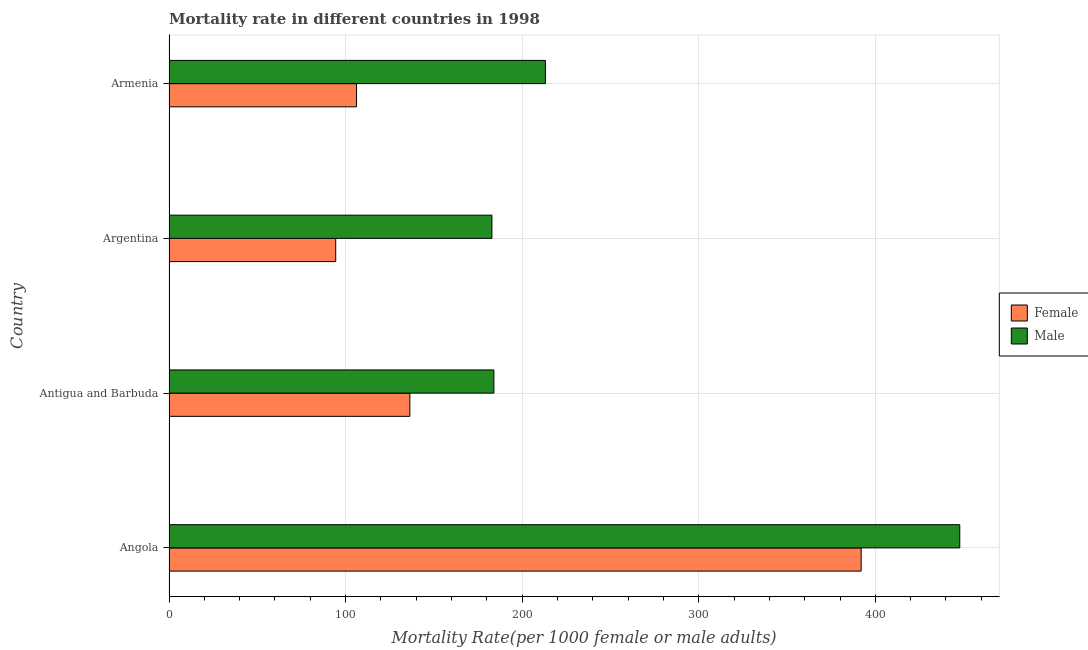How many groups of bars are there?
Make the answer very short. 4. How many bars are there on the 1st tick from the top?
Your response must be concise. 2. What is the label of the 2nd group of bars from the top?
Offer a very short reply. Argentina. In how many cases, is the number of bars for a given country not equal to the number of legend labels?
Offer a very short reply. 0. What is the female mortality rate in Antigua and Barbuda?
Provide a succinct answer. 136.4. Across all countries, what is the maximum female mortality rate?
Your answer should be compact. 391.99. Across all countries, what is the minimum male mortality rate?
Your answer should be compact. 182.88. In which country was the male mortality rate maximum?
Offer a very short reply. Angola. What is the total male mortality rate in the graph?
Offer a terse response. 1027.86. What is the difference between the male mortality rate in Angola and that in Antigua and Barbuda?
Your answer should be very brief. 263.83. What is the difference between the female mortality rate in Argentina and the male mortality rate in Armenia?
Offer a very short reply. -118.75. What is the average female mortality rate per country?
Your response must be concise. 182.25. What is the difference between the female mortality rate and male mortality rate in Argentina?
Your answer should be compact. -88.47. In how many countries, is the male mortality rate greater than 200 ?
Provide a short and direct response. 2. What is the ratio of the female mortality rate in Angola to that in Argentina?
Ensure brevity in your answer.  4.15. Is the difference between the female mortality rate in Angola and Argentina greater than the difference between the male mortality rate in Angola and Argentina?
Your response must be concise. Yes. What is the difference between the highest and the second highest male mortality rate?
Provide a short and direct response. 234.66. What is the difference between the highest and the lowest female mortality rate?
Your answer should be compact. 297.57. In how many countries, is the male mortality rate greater than the average male mortality rate taken over all countries?
Provide a short and direct response. 1. How many bars are there?
Your answer should be compact. 8. Are all the bars in the graph horizontal?
Your response must be concise. Yes. How many countries are there in the graph?
Keep it short and to the point. 4. Does the graph contain grids?
Give a very brief answer. Yes. Where does the legend appear in the graph?
Your answer should be very brief. Center right. How many legend labels are there?
Your answer should be compact. 2. What is the title of the graph?
Make the answer very short. Mortality rate in different countries in 1998. What is the label or title of the X-axis?
Provide a succinct answer. Mortality Rate(per 1000 female or male adults). What is the Mortality Rate(per 1000 female or male adults) of Female in Angola?
Your answer should be very brief. 391.99. What is the Mortality Rate(per 1000 female or male adults) of Male in Angola?
Give a very brief answer. 447.82. What is the Mortality Rate(per 1000 female or male adults) of Female in Antigua and Barbuda?
Your answer should be compact. 136.4. What is the Mortality Rate(per 1000 female or male adults) in Male in Antigua and Barbuda?
Offer a very short reply. 183.99. What is the Mortality Rate(per 1000 female or male adults) in Female in Argentina?
Provide a short and direct response. 94.41. What is the Mortality Rate(per 1000 female or male adults) in Male in Argentina?
Give a very brief answer. 182.88. What is the Mortality Rate(per 1000 female or male adults) of Female in Armenia?
Keep it short and to the point. 106.2. What is the Mortality Rate(per 1000 female or male adults) in Male in Armenia?
Your answer should be compact. 213.16. Across all countries, what is the maximum Mortality Rate(per 1000 female or male adults) in Female?
Your answer should be very brief. 391.99. Across all countries, what is the maximum Mortality Rate(per 1000 female or male adults) in Male?
Your answer should be compact. 447.82. Across all countries, what is the minimum Mortality Rate(per 1000 female or male adults) of Female?
Your answer should be compact. 94.41. Across all countries, what is the minimum Mortality Rate(per 1000 female or male adults) in Male?
Your answer should be very brief. 182.88. What is the total Mortality Rate(per 1000 female or male adults) of Female in the graph?
Keep it short and to the point. 729. What is the total Mortality Rate(per 1000 female or male adults) of Male in the graph?
Your response must be concise. 1027.86. What is the difference between the Mortality Rate(per 1000 female or male adults) in Female in Angola and that in Antigua and Barbuda?
Keep it short and to the point. 255.59. What is the difference between the Mortality Rate(per 1000 female or male adults) in Male in Angola and that in Antigua and Barbuda?
Give a very brief answer. 263.83. What is the difference between the Mortality Rate(per 1000 female or male adults) in Female in Angola and that in Argentina?
Your response must be concise. 297.57. What is the difference between the Mortality Rate(per 1000 female or male adults) in Male in Angola and that in Argentina?
Offer a terse response. 264.94. What is the difference between the Mortality Rate(per 1000 female or male adults) in Female in Angola and that in Armenia?
Give a very brief answer. 285.79. What is the difference between the Mortality Rate(per 1000 female or male adults) of Male in Angola and that in Armenia?
Provide a succinct answer. 234.66. What is the difference between the Mortality Rate(per 1000 female or male adults) in Female in Antigua and Barbuda and that in Argentina?
Give a very brief answer. 41.99. What is the difference between the Mortality Rate(per 1000 female or male adults) in Male in Antigua and Barbuda and that in Argentina?
Your answer should be very brief. 1.11. What is the difference between the Mortality Rate(per 1000 female or male adults) of Female in Antigua and Barbuda and that in Armenia?
Keep it short and to the point. 30.2. What is the difference between the Mortality Rate(per 1000 female or male adults) of Male in Antigua and Barbuda and that in Armenia?
Offer a terse response. -29.17. What is the difference between the Mortality Rate(per 1000 female or male adults) in Female in Argentina and that in Armenia?
Provide a succinct answer. -11.79. What is the difference between the Mortality Rate(per 1000 female or male adults) of Male in Argentina and that in Armenia?
Offer a very short reply. -30.28. What is the difference between the Mortality Rate(per 1000 female or male adults) in Female in Angola and the Mortality Rate(per 1000 female or male adults) in Male in Antigua and Barbuda?
Offer a terse response. 207.99. What is the difference between the Mortality Rate(per 1000 female or male adults) in Female in Angola and the Mortality Rate(per 1000 female or male adults) in Male in Argentina?
Offer a terse response. 209.11. What is the difference between the Mortality Rate(per 1000 female or male adults) of Female in Angola and the Mortality Rate(per 1000 female or male adults) of Male in Armenia?
Your answer should be very brief. 178.82. What is the difference between the Mortality Rate(per 1000 female or male adults) in Female in Antigua and Barbuda and the Mortality Rate(per 1000 female or male adults) in Male in Argentina?
Make the answer very short. -46.48. What is the difference between the Mortality Rate(per 1000 female or male adults) in Female in Antigua and Barbuda and the Mortality Rate(per 1000 female or male adults) in Male in Armenia?
Your response must be concise. -76.76. What is the difference between the Mortality Rate(per 1000 female or male adults) of Female in Argentina and the Mortality Rate(per 1000 female or male adults) of Male in Armenia?
Make the answer very short. -118.75. What is the average Mortality Rate(per 1000 female or male adults) of Female per country?
Offer a very short reply. 182.25. What is the average Mortality Rate(per 1000 female or male adults) of Male per country?
Your answer should be very brief. 256.96. What is the difference between the Mortality Rate(per 1000 female or male adults) of Female and Mortality Rate(per 1000 female or male adults) of Male in Angola?
Your answer should be very brief. -55.84. What is the difference between the Mortality Rate(per 1000 female or male adults) of Female and Mortality Rate(per 1000 female or male adults) of Male in Antigua and Barbuda?
Offer a terse response. -47.59. What is the difference between the Mortality Rate(per 1000 female or male adults) of Female and Mortality Rate(per 1000 female or male adults) of Male in Argentina?
Offer a terse response. -88.47. What is the difference between the Mortality Rate(per 1000 female or male adults) in Female and Mortality Rate(per 1000 female or male adults) in Male in Armenia?
Your response must be concise. -106.96. What is the ratio of the Mortality Rate(per 1000 female or male adults) in Female in Angola to that in Antigua and Barbuda?
Make the answer very short. 2.87. What is the ratio of the Mortality Rate(per 1000 female or male adults) of Male in Angola to that in Antigua and Barbuda?
Your answer should be very brief. 2.43. What is the ratio of the Mortality Rate(per 1000 female or male adults) of Female in Angola to that in Argentina?
Your answer should be compact. 4.15. What is the ratio of the Mortality Rate(per 1000 female or male adults) in Male in Angola to that in Argentina?
Ensure brevity in your answer.  2.45. What is the ratio of the Mortality Rate(per 1000 female or male adults) of Female in Angola to that in Armenia?
Give a very brief answer. 3.69. What is the ratio of the Mortality Rate(per 1000 female or male adults) in Male in Angola to that in Armenia?
Your response must be concise. 2.1. What is the ratio of the Mortality Rate(per 1000 female or male adults) of Female in Antigua and Barbuda to that in Argentina?
Offer a very short reply. 1.44. What is the ratio of the Mortality Rate(per 1000 female or male adults) of Male in Antigua and Barbuda to that in Argentina?
Offer a very short reply. 1.01. What is the ratio of the Mortality Rate(per 1000 female or male adults) of Female in Antigua and Barbuda to that in Armenia?
Provide a succinct answer. 1.28. What is the ratio of the Mortality Rate(per 1000 female or male adults) of Male in Antigua and Barbuda to that in Armenia?
Offer a terse response. 0.86. What is the ratio of the Mortality Rate(per 1000 female or male adults) of Female in Argentina to that in Armenia?
Ensure brevity in your answer.  0.89. What is the ratio of the Mortality Rate(per 1000 female or male adults) in Male in Argentina to that in Armenia?
Ensure brevity in your answer.  0.86. What is the difference between the highest and the second highest Mortality Rate(per 1000 female or male adults) in Female?
Provide a succinct answer. 255.59. What is the difference between the highest and the second highest Mortality Rate(per 1000 female or male adults) of Male?
Give a very brief answer. 234.66. What is the difference between the highest and the lowest Mortality Rate(per 1000 female or male adults) of Female?
Make the answer very short. 297.57. What is the difference between the highest and the lowest Mortality Rate(per 1000 female or male adults) of Male?
Offer a very short reply. 264.94. 